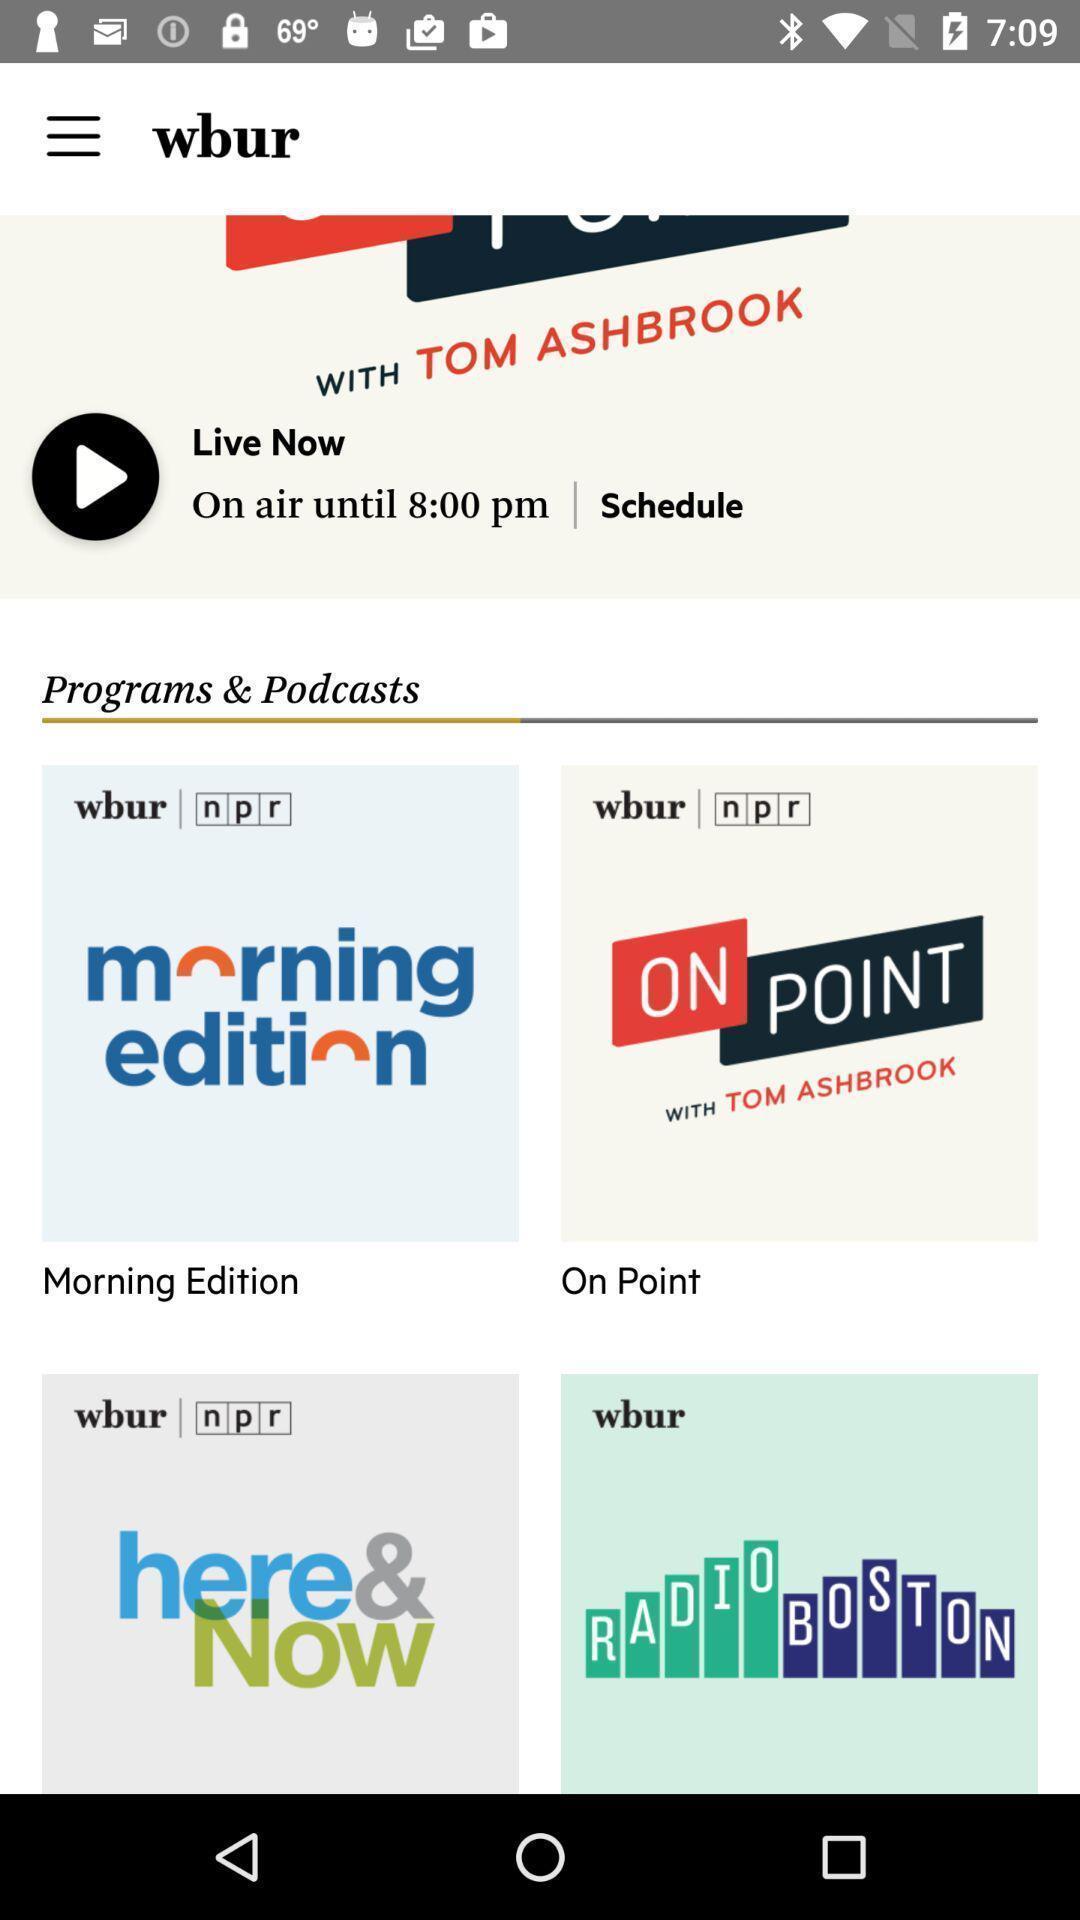Describe the content in this image. Various kinds of programs in the podcast. 